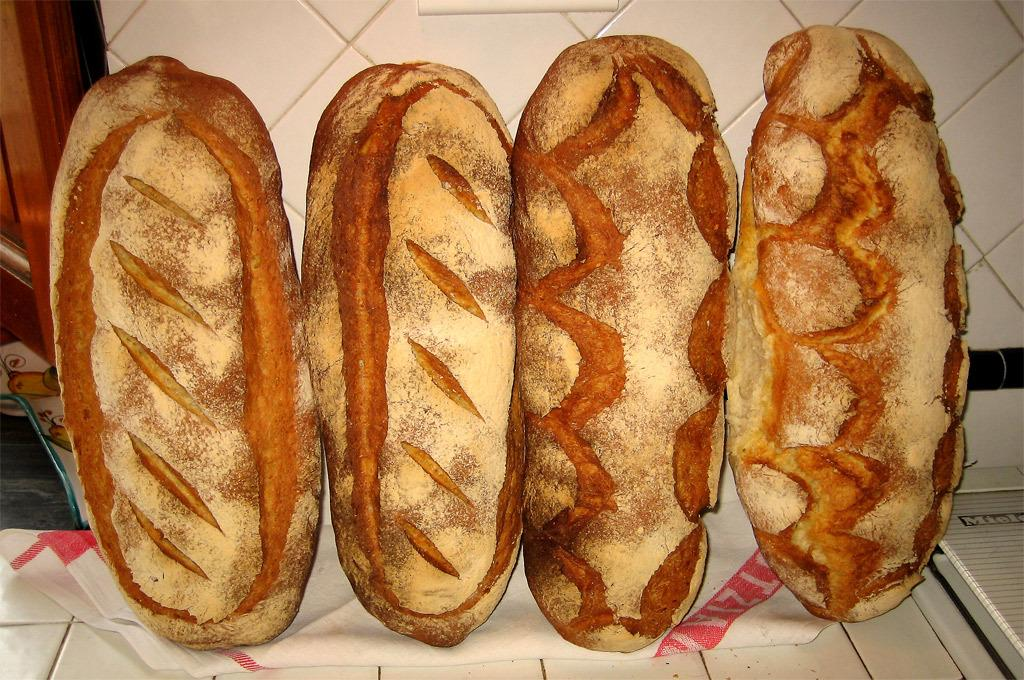How many hot dogs are visible in the image? There are four hot dogs in the image. How are the hot dogs arranged in the image? The hot dogs are placed vertically. What might be used for cleaning or wiping in the image? There is a paper napkin in the image. Is there a crown visible on any of the hot dogs in the image? No, there is no crown present on any of the hot dogs in the image. 